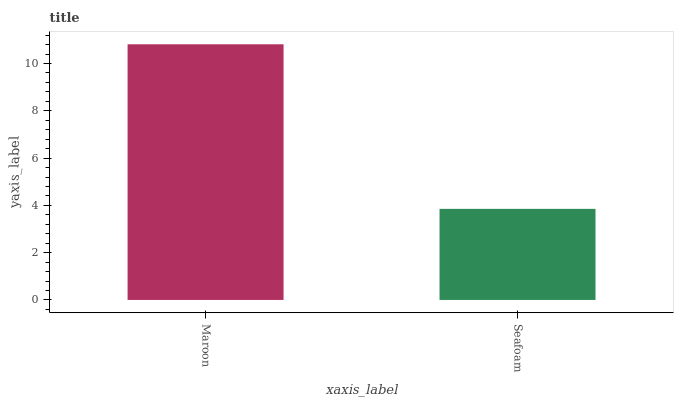Is Seafoam the minimum?
Answer yes or no. Yes. Is Maroon the maximum?
Answer yes or no. Yes. Is Seafoam the maximum?
Answer yes or no. No. Is Maroon greater than Seafoam?
Answer yes or no. Yes. Is Seafoam less than Maroon?
Answer yes or no. Yes. Is Seafoam greater than Maroon?
Answer yes or no. No. Is Maroon less than Seafoam?
Answer yes or no. No. Is Maroon the high median?
Answer yes or no. Yes. Is Seafoam the low median?
Answer yes or no. Yes. Is Seafoam the high median?
Answer yes or no. No. Is Maroon the low median?
Answer yes or no. No. 